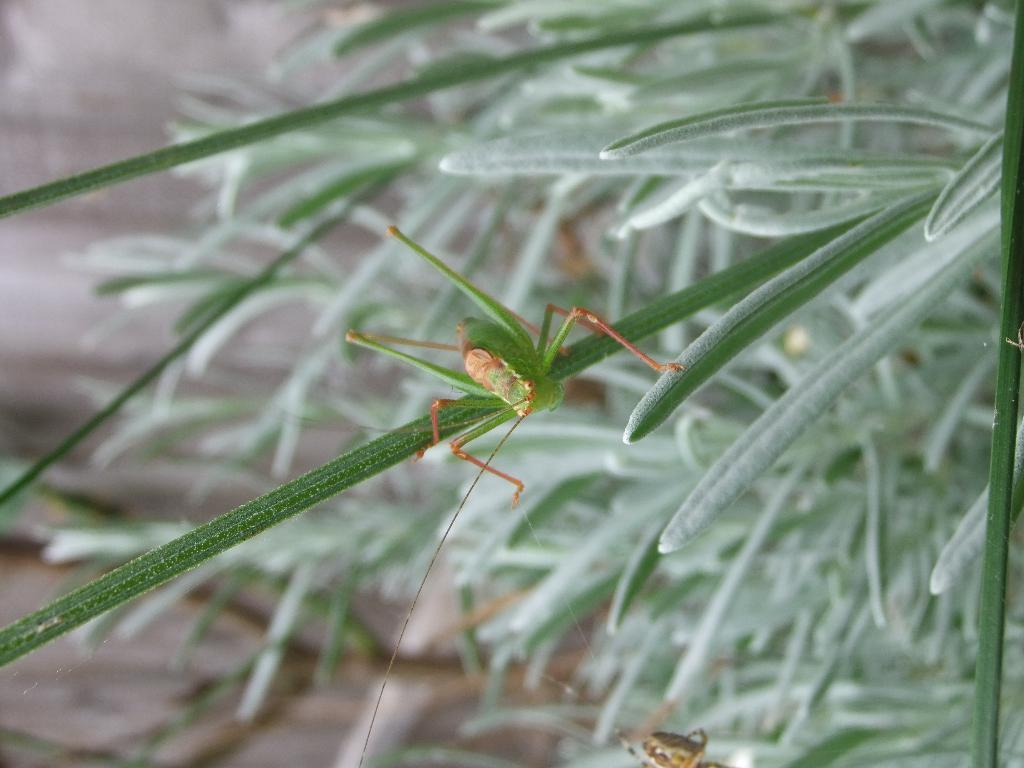What is the main subject in the center of the image? There is a grasshopper in the center of the image. What type of vegetation can be seen on the right side of the image? Leaves are present on the right side of the image. What is visible on the left side of the image? The ground is visible on the left side of the image. What type of behavior does the grasshopper exhibit in the image? The image does not show the grasshopper's behavior, only its presence in the center of the image. 